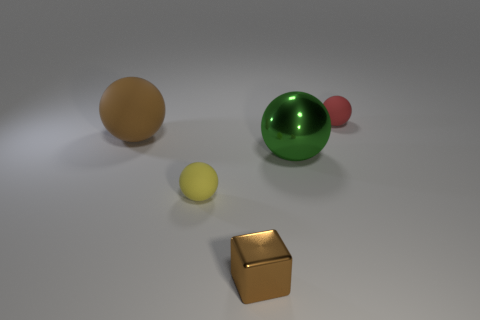Subtract all purple balls. Subtract all brown cubes. How many balls are left? 4 Add 1 big brown matte cylinders. How many objects exist? 6 Subtract all blocks. How many objects are left? 4 Subtract all yellow matte balls. Subtract all big green shiny balls. How many objects are left? 3 Add 1 large shiny objects. How many large shiny objects are left? 2 Add 5 brown metallic cubes. How many brown metallic cubes exist? 6 Subtract 0 cyan spheres. How many objects are left? 5 